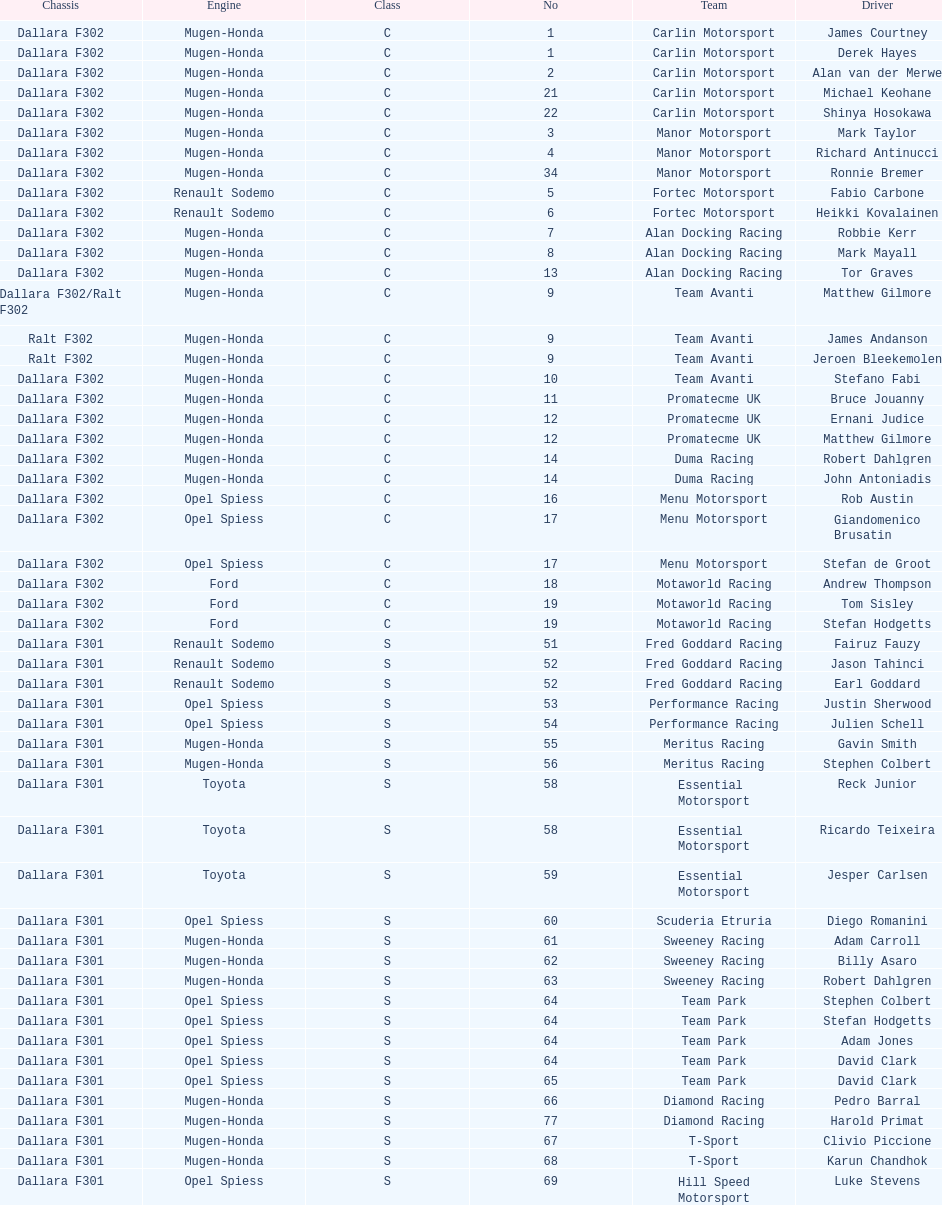What is the number of teams that had drivers all from the same country? 4. 